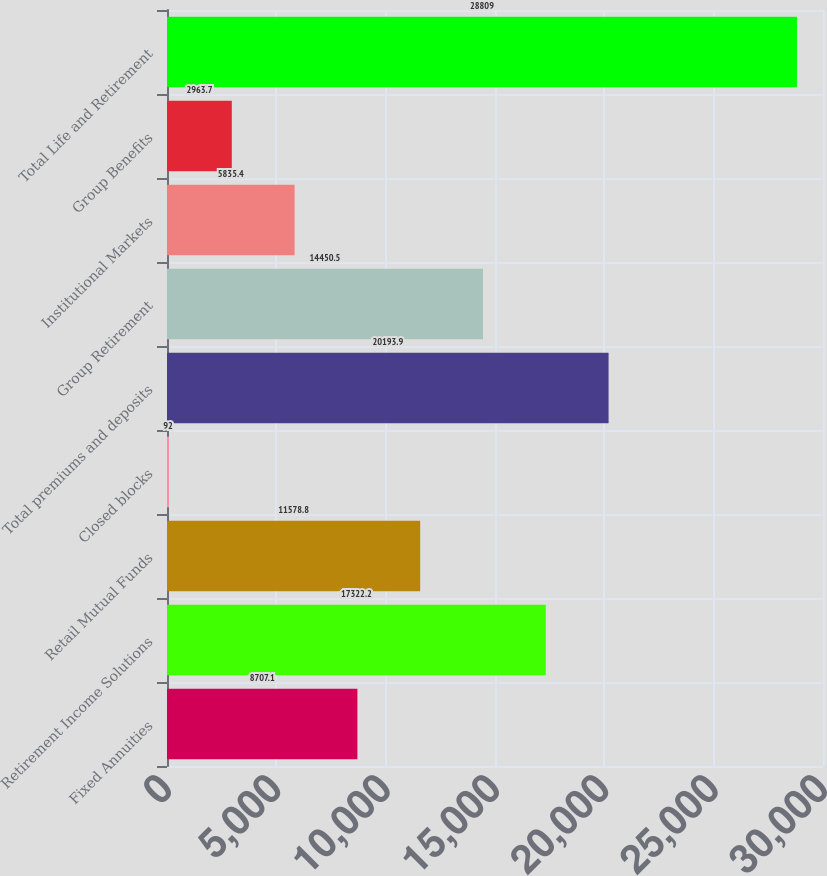<chart> <loc_0><loc_0><loc_500><loc_500><bar_chart><fcel>Fixed Annuities<fcel>Retirement Income Solutions<fcel>Retail Mutual Funds<fcel>Closed blocks<fcel>Total premiums and deposits<fcel>Group Retirement<fcel>Institutional Markets<fcel>Group Benefits<fcel>Total Life and Retirement<nl><fcel>8707.1<fcel>17322.2<fcel>11578.8<fcel>92<fcel>20193.9<fcel>14450.5<fcel>5835.4<fcel>2963.7<fcel>28809<nl></chart> 